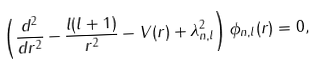Convert formula to latex. <formula><loc_0><loc_0><loc_500><loc_500>\left ( \frac { d ^ { 2 } } { d r ^ { 2 } } - \frac { l ( l + 1 ) } { r ^ { 2 } } - V ( r ) + \lambda ^ { 2 } _ { n , l } \right ) \phi _ { n , l } ( r ) = 0 ,</formula> 